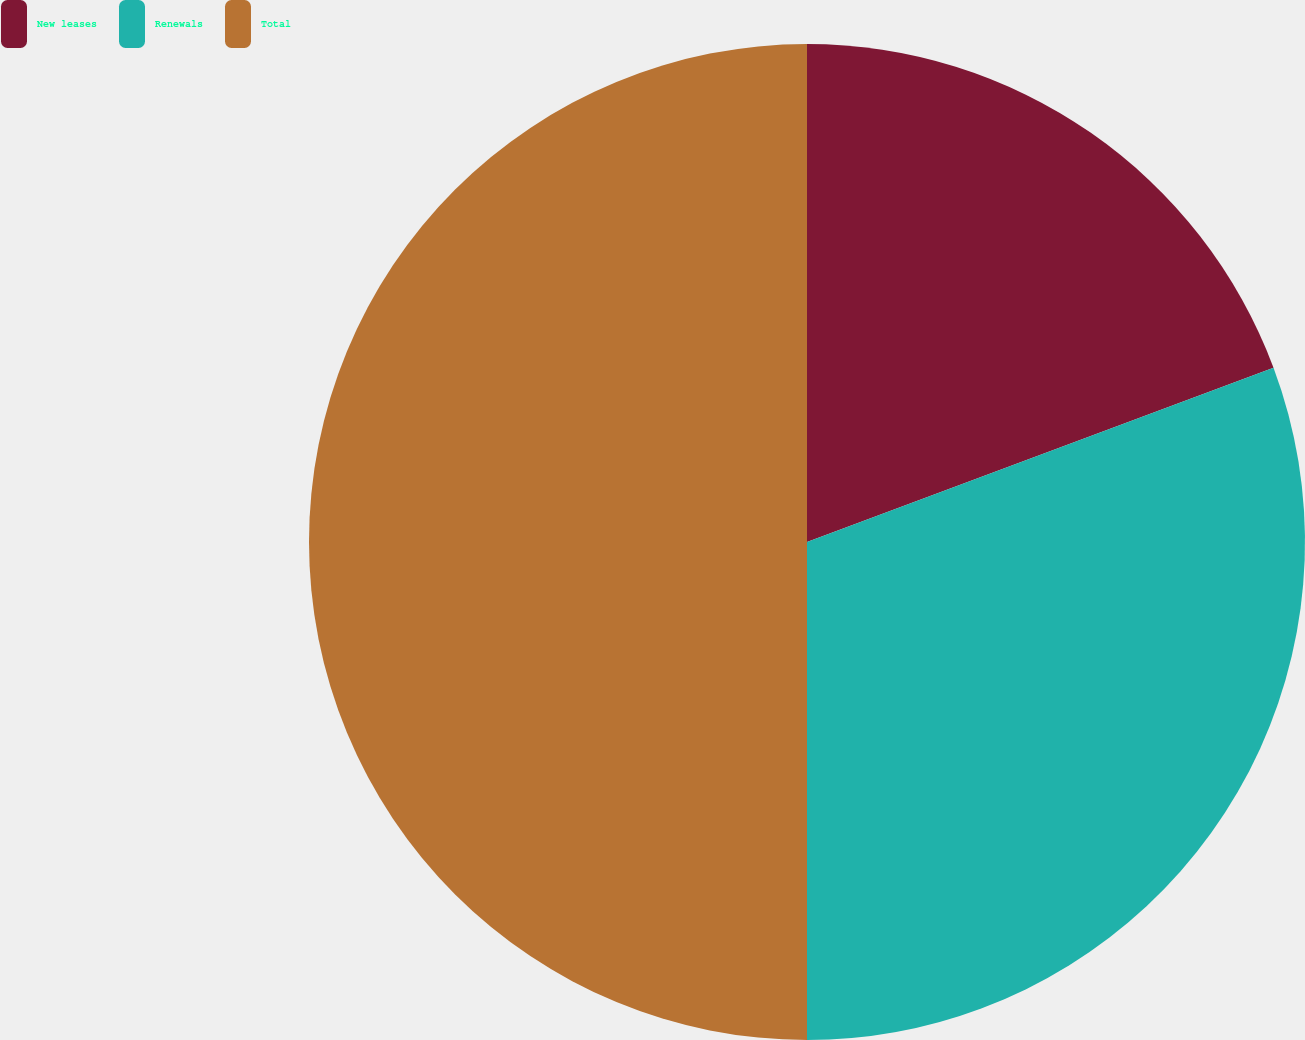Convert chart to OTSL. <chart><loc_0><loc_0><loc_500><loc_500><pie_chart><fcel>New leases<fcel>Renewals<fcel>Total<nl><fcel>19.31%<fcel>30.69%<fcel>50.0%<nl></chart> 